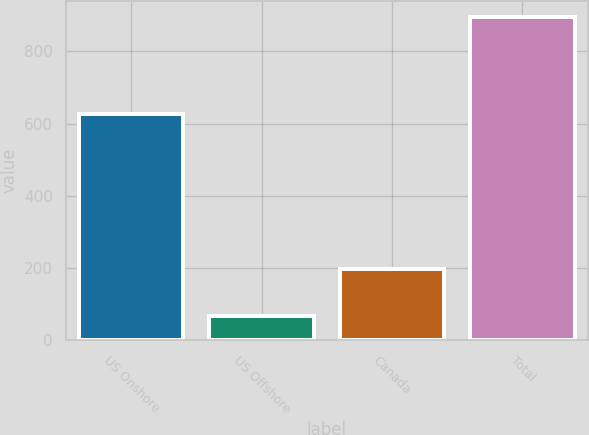<chart> <loc_0><loc_0><loc_500><loc_500><bar_chart><fcel>US Onshore<fcel>US Offshore<fcel>Canada<fcel>Total<nl><fcel>626<fcel>68<fcel>198<fcel>894<nl></chart> 